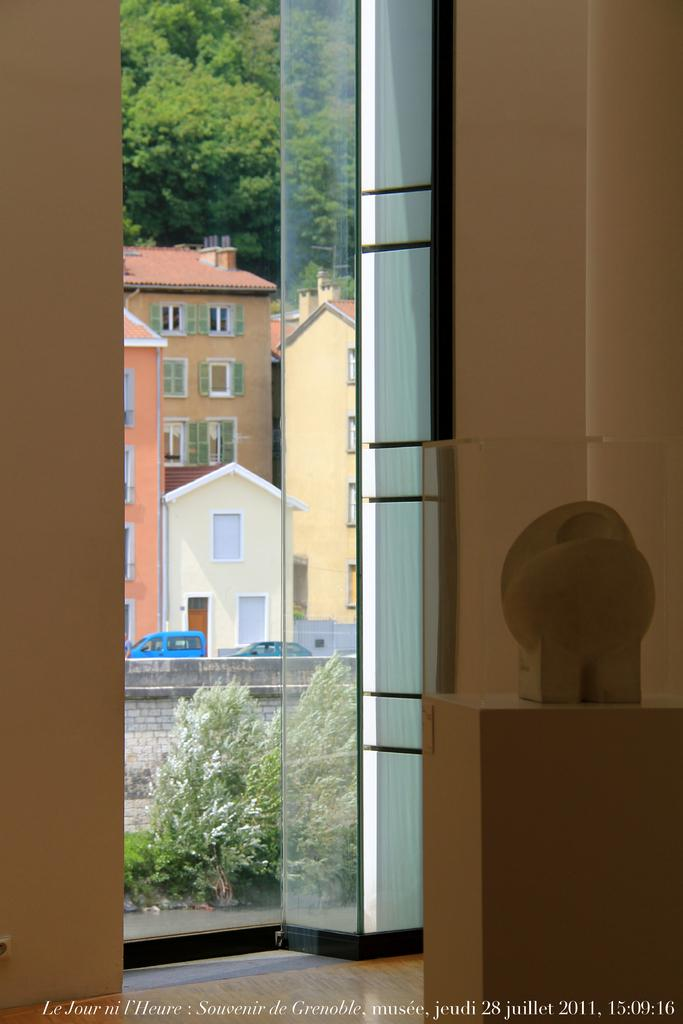What color are the walls in the image? The walls in the image are brown colored. What is on the floor in the image? There is a brown colored object on the floor. Can you describe the door in the image? Yes, there is a door in the image. What can be seen through the door in the image? Buildings, trees, and vehicles can be seen through the door in the image. Who is the owner of the baby in the image? There is no baby present in the image, so it is not possible to determine the owner. 